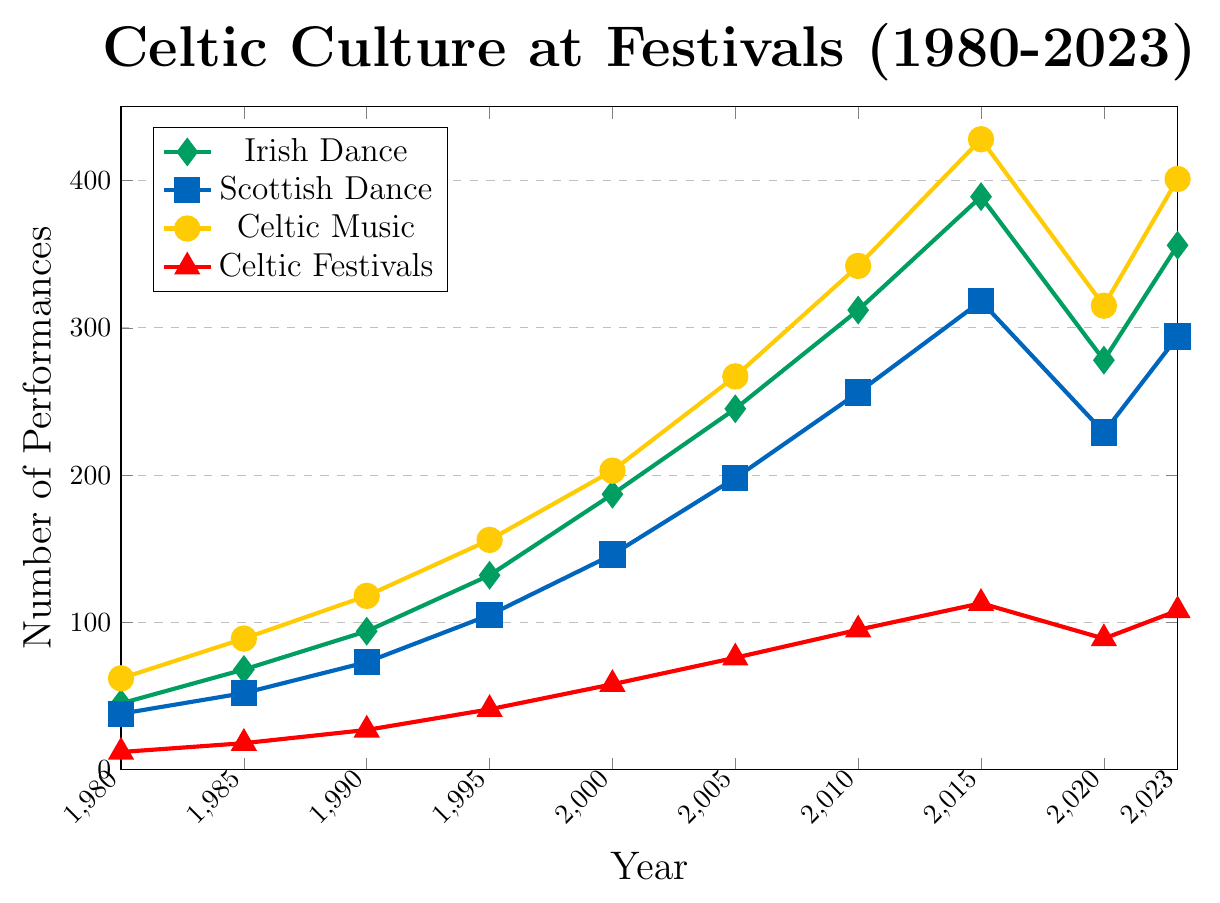What year had the highest number of Irish Dance Performances? By examining the green diamond data points on the chart, we can see that 2015 had the highest number of Irish Dance Performances, with 389 performances.
Answer: 2015 What is the difference in the number of Scottish Dance Performances between 2015 and 2020? The number of Scottish Dance Performances in 2015 was 318, and in 2020 it was 229. The difference is 318 - 229 = 89.
Answer: 89 How many total performances were there in 2005 for Celtic Festivals, Irish Dance, Scottish Dance, and Celtic Music Concerts combined? Sum the values for each category in 2005: 76 (Celtic Festivals) + 245 (Irish Dance) + 198 (Scottish Dance) + 267 (Celtic Music Concerts) = 786.
Answer: 786 Which category had the most performances in 2023? By looking at the chart for 2023, we see the following: Irish Dance (356), Scottish Dance (294), Celtic Music Concerts (401), and Celtic Festivals (108). Celtic Music Concerts had the most performances with 401.
Answer: Celtic Music Concerts What was the average number of Irish Dance Performances from 1980 to 2023? To find the average, sum the values of Irish Dance Performances: 45 + 68 + 94 + 132 + 187 + 245 + 312 + 389 + 278 + 356 = 2106. There are 10 data points, so 2106 / 10 = 210.6.
Answer: 210.6 How does the number of Celtic Festivals in 1995 compare to 2023? The chart shows that there were 41 Celtic Festivals in 1995 and 108 in 2023. Therefore, there were more Celtic Festivals in 2023 than in 1995.
Answer: More in 2023 What is the combined number of Irish and Scottish Dance Performances in 2020? Sum the number of Irish Dance (278) and Scottish Dance Performances (229) in 2020: 278 + 229 = 507.
Answer: 507 What year saw the biggest increase in Celtic Music Concerts compared to the previous data point? Calculate the increase for each year: 
1985 - 1980: 89 - 62 = 27
1990 - 1985: 118 - 89 = 29
1995 - 1990: 156 - 118 = 38
2000 - 1995: 203 - 156 = 47
2005 - 2000: 267 - 203 = 64
2010 - 2005: 342 - 267 = 75
2015 - 2010: 428 - 342 = 86
2020 - 2015: 315 - 428 = -113
2023 - 2020: 401 - 315 = 86
The biggest increase was 86, in both 2015 and 2023 compared to the previous points.
Answer: 2015 or 2023 